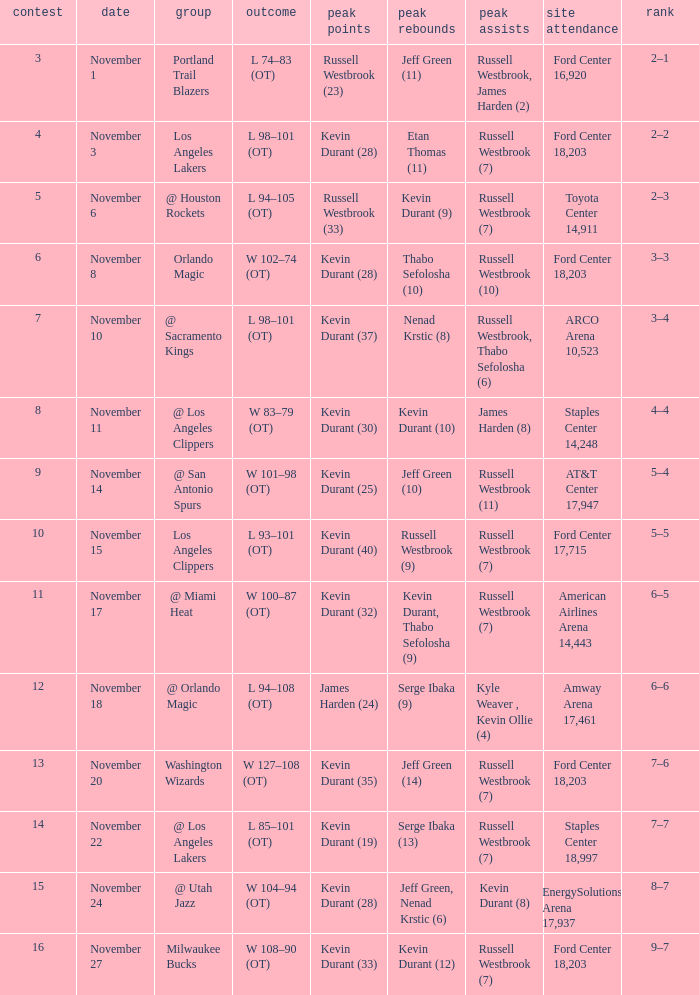What was the record in the game in which Jeff Green (14) did the most high rebounds? 7–6. 